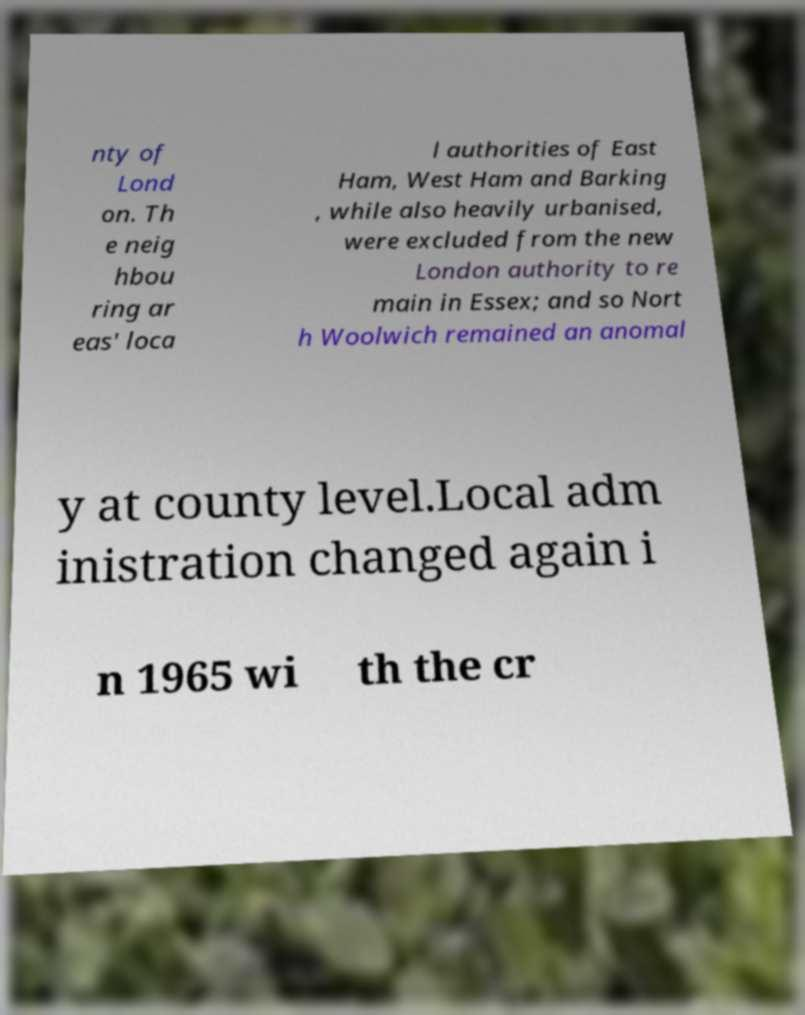For documentation purposes, I need the text within this image transcribed. Could you provide that? nty of Lond on. Th e neig hbou ring ar eas' loca l authorities of East Ham, West Ham and Barking , while also heavily urbanised, were excluded from the new London authority to re main in Essex; and so Nort h Woolwich remained an anomal y at county level.Local adm inistration changed again i n 1965 wi th the cr 